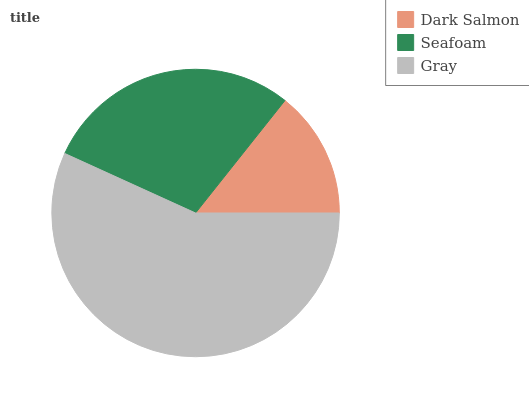Is Dark Salmon the minimum?
Answer yes or no. Yes. Is Gray the maximum?
Answer yes or no. Yes. Is Seafoam the minimum?
Answer yes or no. No. Is Seafoam the maximum?
Answer yes or no. No. Is Seafoam greater than Dark Salmon?
Answer yes or no. Yes. Is Dark Salmon less than Seafoam?
Answer yes or no. Yes. Is Dark Salmon greater than Seafoam?
Answer yes or no. No. Is Seafoam less than Dark Salmon?
Answer yes or no. No. Is Seafoam the high median?
Answer yes or no. Yes. Is Seafoam the low median?
Answer yes or no. Yes. Is Gray the high median?
Answer yes or no. No. Is Gray the low median?
Answer yes or no. No. 